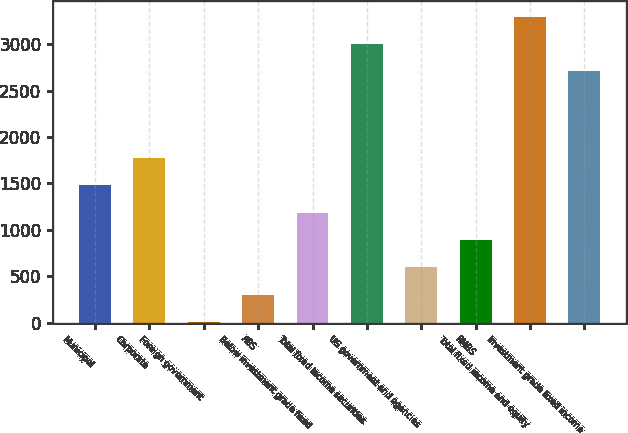Convert chart. <chart><loc_0><loc_0><loc_500><loc_500><bar_chart><fcel>Municipal<fcel>Corporate<fcel>Foreign government<fcel>ABS<fcel>Below investment grade fixed<fcel>Total fixed income securities<fcel>US government and agencies<fcel>RMBS<fcel>Total fixed income and equity<fcel>Investment grade fixed income<nl><fcel>1480<fcel>1774.6<fcel>7<fcel>301.6<fcel>1185.4<fcel>3000.6<fcel>596.2<fcel>890.8<fcel>3295.2<fcel>2706<nl></chart> 